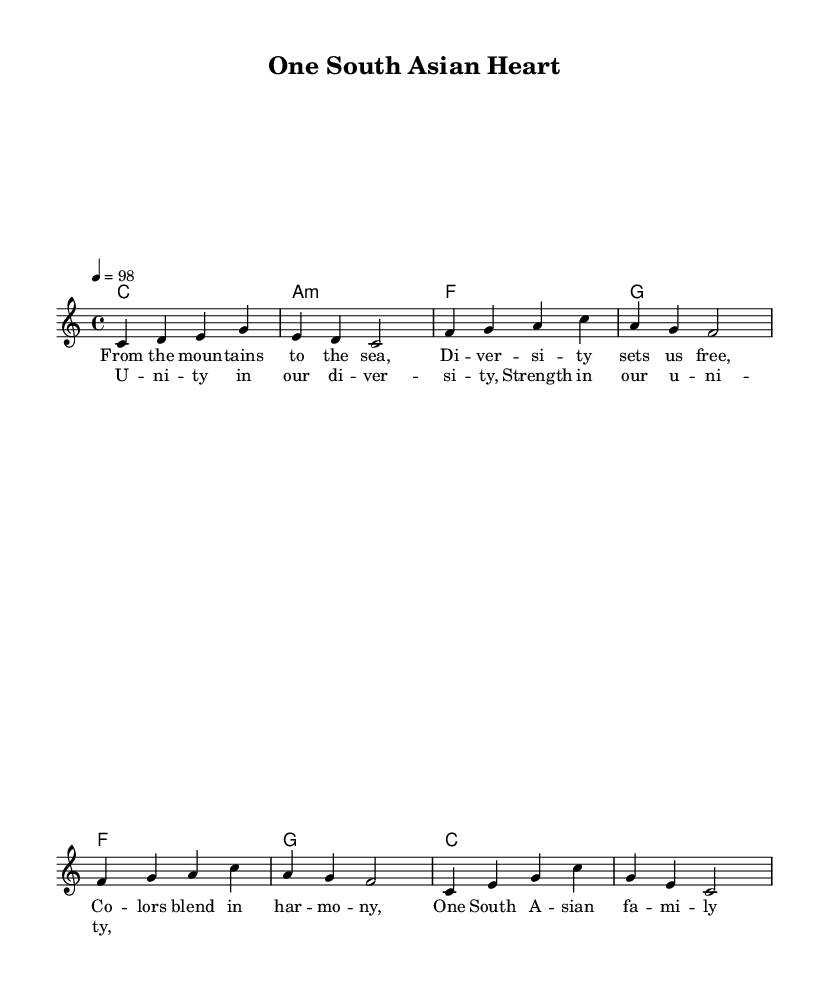What is the key signature of this music? The key signature is indicated at the beginning of the staff, showing that it is C major, which has no sharps or flats.
Answer: C major What is the time signature of this piece? The time signature is shown as a fraction at the beginning, indicating that there are four beats in each measure and the quarter note gets one beat.
Answer: 4/4 What is the tempo marking for this piece? The tempo marking provided at the beginning indicates a speed of 98 beats per minute, which is a moderate tempo for reggae music.
Answer: 98 How many measures are in the verse? By counting the individual segments marked in the melody section, we can see there are four measures in the verse which correspond to the lyrics.
Answer: 4 What is the first chord in the verse? The first chord is the first note of the chord progression noted under the verse section, which is C major.
Answer: C What theme is represented in the chorus lyrics? Analyzing the chorus lyrics, the focus is on unity within diversity, which is a central theme in reggae music highlighting cultural connections.
Answer: Unity in diversity What elements signify its reggae style? The use of syncopated rhythms, off-beat chords, and themes of cultural celebration within the lyrics all are characteristic of reggae music style.
Answer: Syncopation and cultural themes 